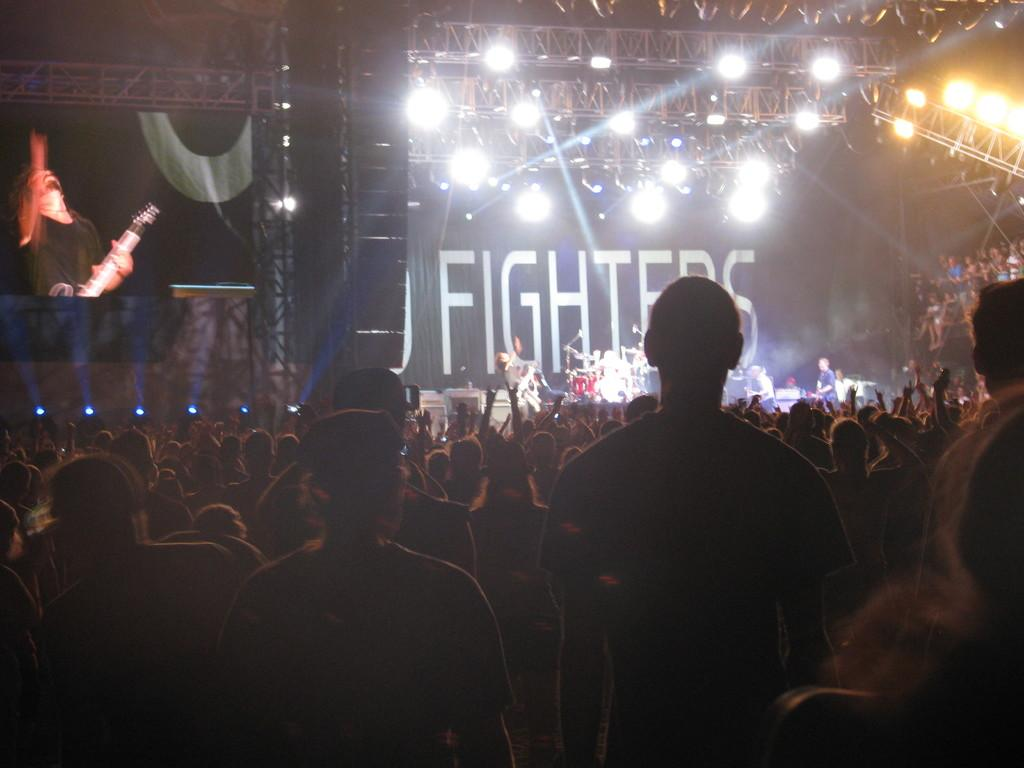What type of event is happening in the image? A concert is taking place. Can you describe the people present at the event? People are present at the concert. What musical instrument can be seen on the stage? There are drums on the stage. What type of lighting is present at the event? There are lights at the event. What is located on the left side of the stage? There is a screen on the left side of the stage. What type of map is being used for arithmetic calculations during the day at the concert? There is no map or arithmetic calculations present in the image; it is a concert with drums, lights, and a screen on the stage. 